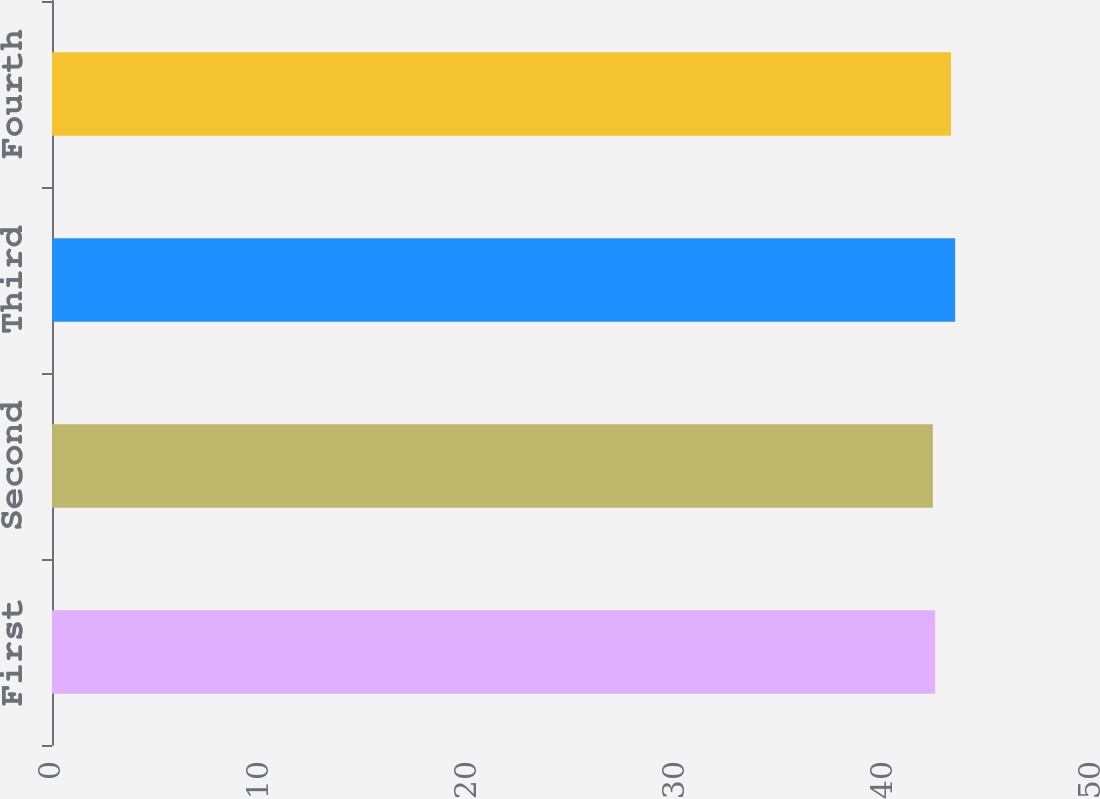Convert chart. <chart><loc_0><loc_0><loc_500><loc_500><bar_chart><fcel>First<fcel>Second<fcel>Third<fcel>Fourth<nl><fcel>42.46<fcel>42.35<fcel>43.42<fcel>43.22<nl></chart> 